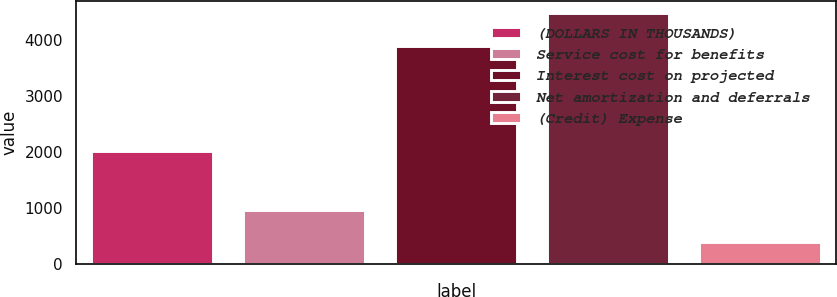Convert chart. <chart><loc_0><loc_0><loc_500><loc_500><bar_chart><fcel>(DOLLARS IN THOUSANDS)<fcel>Service cost for benefits<fcel>Interest cost on projected<fcel>Net amortization and deferrals<fcel>(Credit) Expense<nl><fcel>2015<fcel>966<fcel>3904<fcel>4476<fcel>394<nl></chart> 